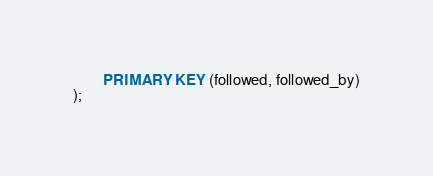Convert code to text. <code><loc_0><loc_0><loc_500><loc_500><_SQL_>        PRIMARY KEY (followed, followed_by)
);</code> 